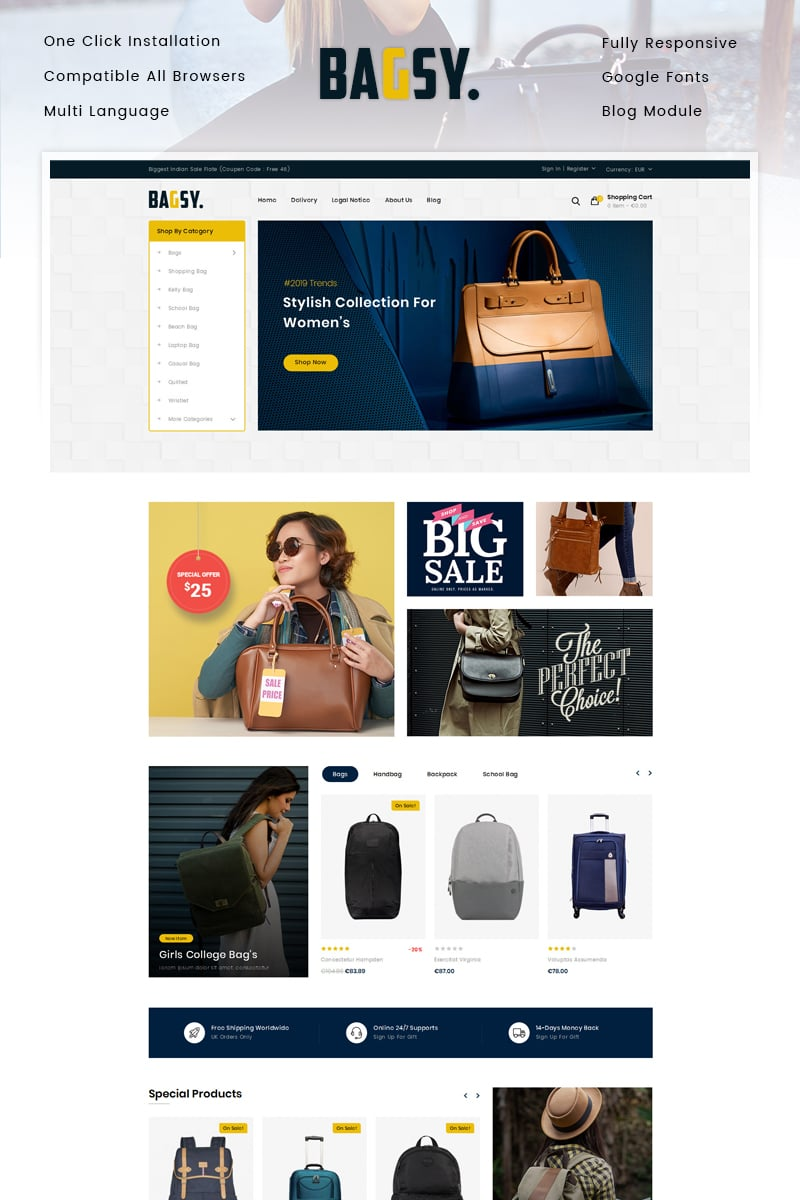What demographic seems to be the primary target audience for the "BAGSY" online store based on the imagery and product selection? The BAGSY online store primarily targets fashion-oriented young to middle-aged women, distinguished by the curated imagery and product selections showcased on the website. Prominent promotional banners feature young women carrying stylish, contemporary handbags, underscoring a focus on modern fashion trends that appeal to a youthful, trend-conscious female audience. Products highlighted, such as 'Girls College Bag’s' and various trendy handbags displayed on sale, specifically cater to the aesthetic preferences and practical needs of female students and young professionals. Moreover, the sleek design and modern typography of the website further appeal to a style-savvy clientele seeking fashion-forward accessories. 